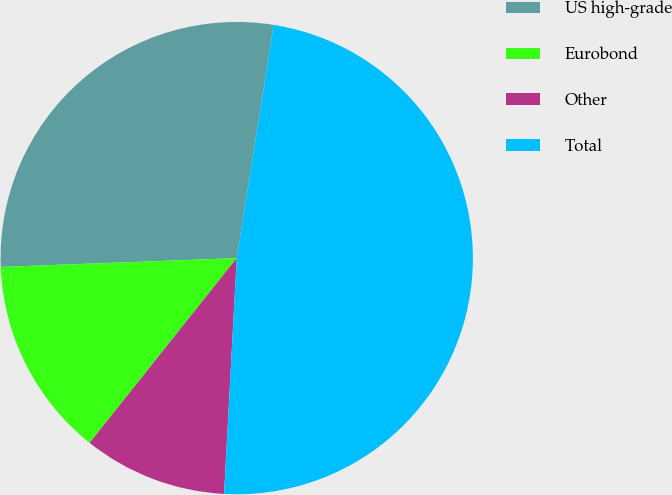Convert chart. <chart><loc_0><loc_0><loc_500><loc_500><pie_chart><fcel>US high-grade<fcel>Eurobond<fcel>Other<fcel>Total<nl><fcel>28.1%<fcel>13.7%<fcel>9.85%<fcel>48.35%<nl></chart> 